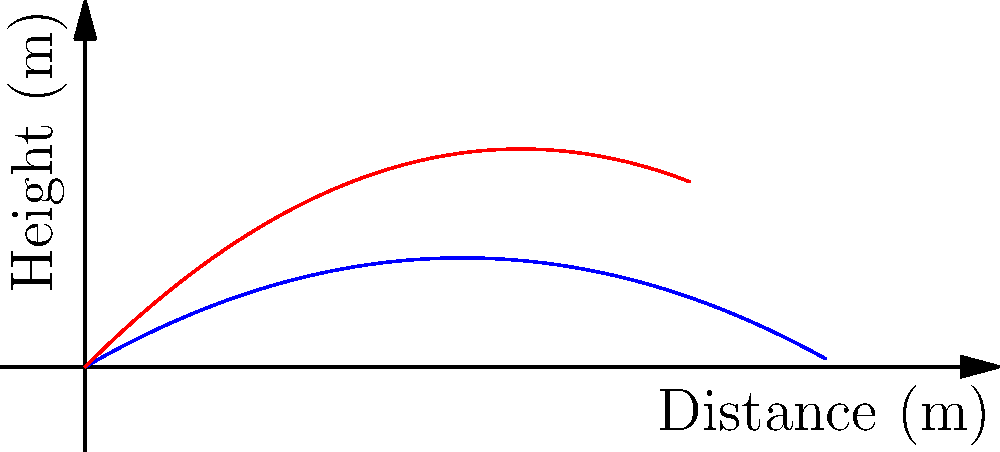As a football coach, you're teaching your players about the importance of kick angles. A player kicks a football with an initial velocity of 20 m/s at two different angles: 30° and 45°. Using the graph provided, which angle results in the football traveling a greater horizontal distance, and approximately how much farther does it travel? To solve this problem, we'll analyze the graph and use our knowledge of projectile motion:

1. The blue curve represents the trajectory for the 30° kick, while the red curve represents the 45° kick.

2. The horizontal distance traveled is determined by where each curve intersects the x-axis (y = 0).

3. From the graph, we can see that the blue curve (30° kick) extends further along the x-axis before intersecting it.

4. To estimate the difference, we can approximate the landing points:
   - 30° kick: lands at about 35 meters
   - 45° kick: lands at about 32 meters

5. The difference in horizontal distance is approximately:
   35 m - 32 m = 3 m

6. Therefore, the 30° kick travels about 3 meters farther than the 45° kick.

This result might seem counterintuitive, but it's due to the trade-off between horizontal and vertical components of velocity. While a 45° angle maximizes height, it doesn't always maximize distance, especially when air resistance is considered (which is not factored into this simple model).
Answer: 30° angle; approximately 3 meters farther. 